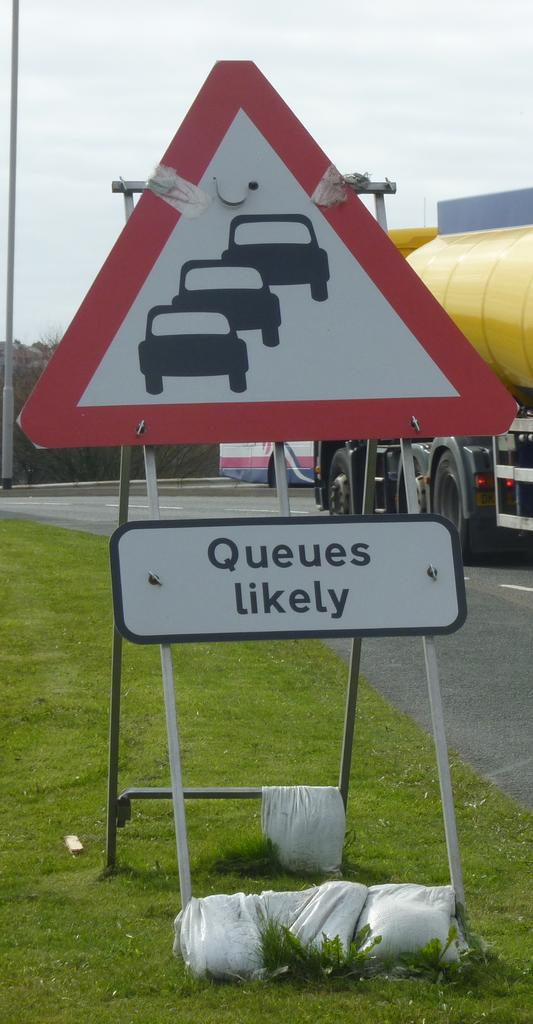What type of surface is on the ground in the image? There is grass on the ground in the image. What structures can be seen in the image? There are poles and a signboard in the image. What is written or displayed on the signboard? There is a board with text in the image. What type of pathway is visible in the image? There is a road in the image. What mode of transportation is present in the image? There is a vehicle in the image. What type of vegetation is present in the image? There are trees in the image. What part of the natural environment is visible in the image? The sky is visible in the image. How many maids are visible in the image? There are no maids present in the image. What type of ticket can be seen in the image? There is no ticket present in the image. 